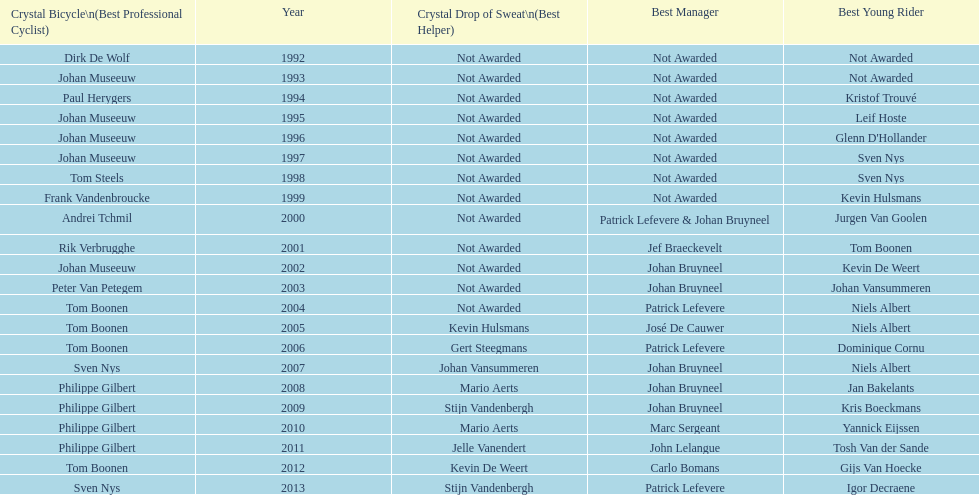Who won the most consecutive crystal bicycles? Philippe Gilbert. 